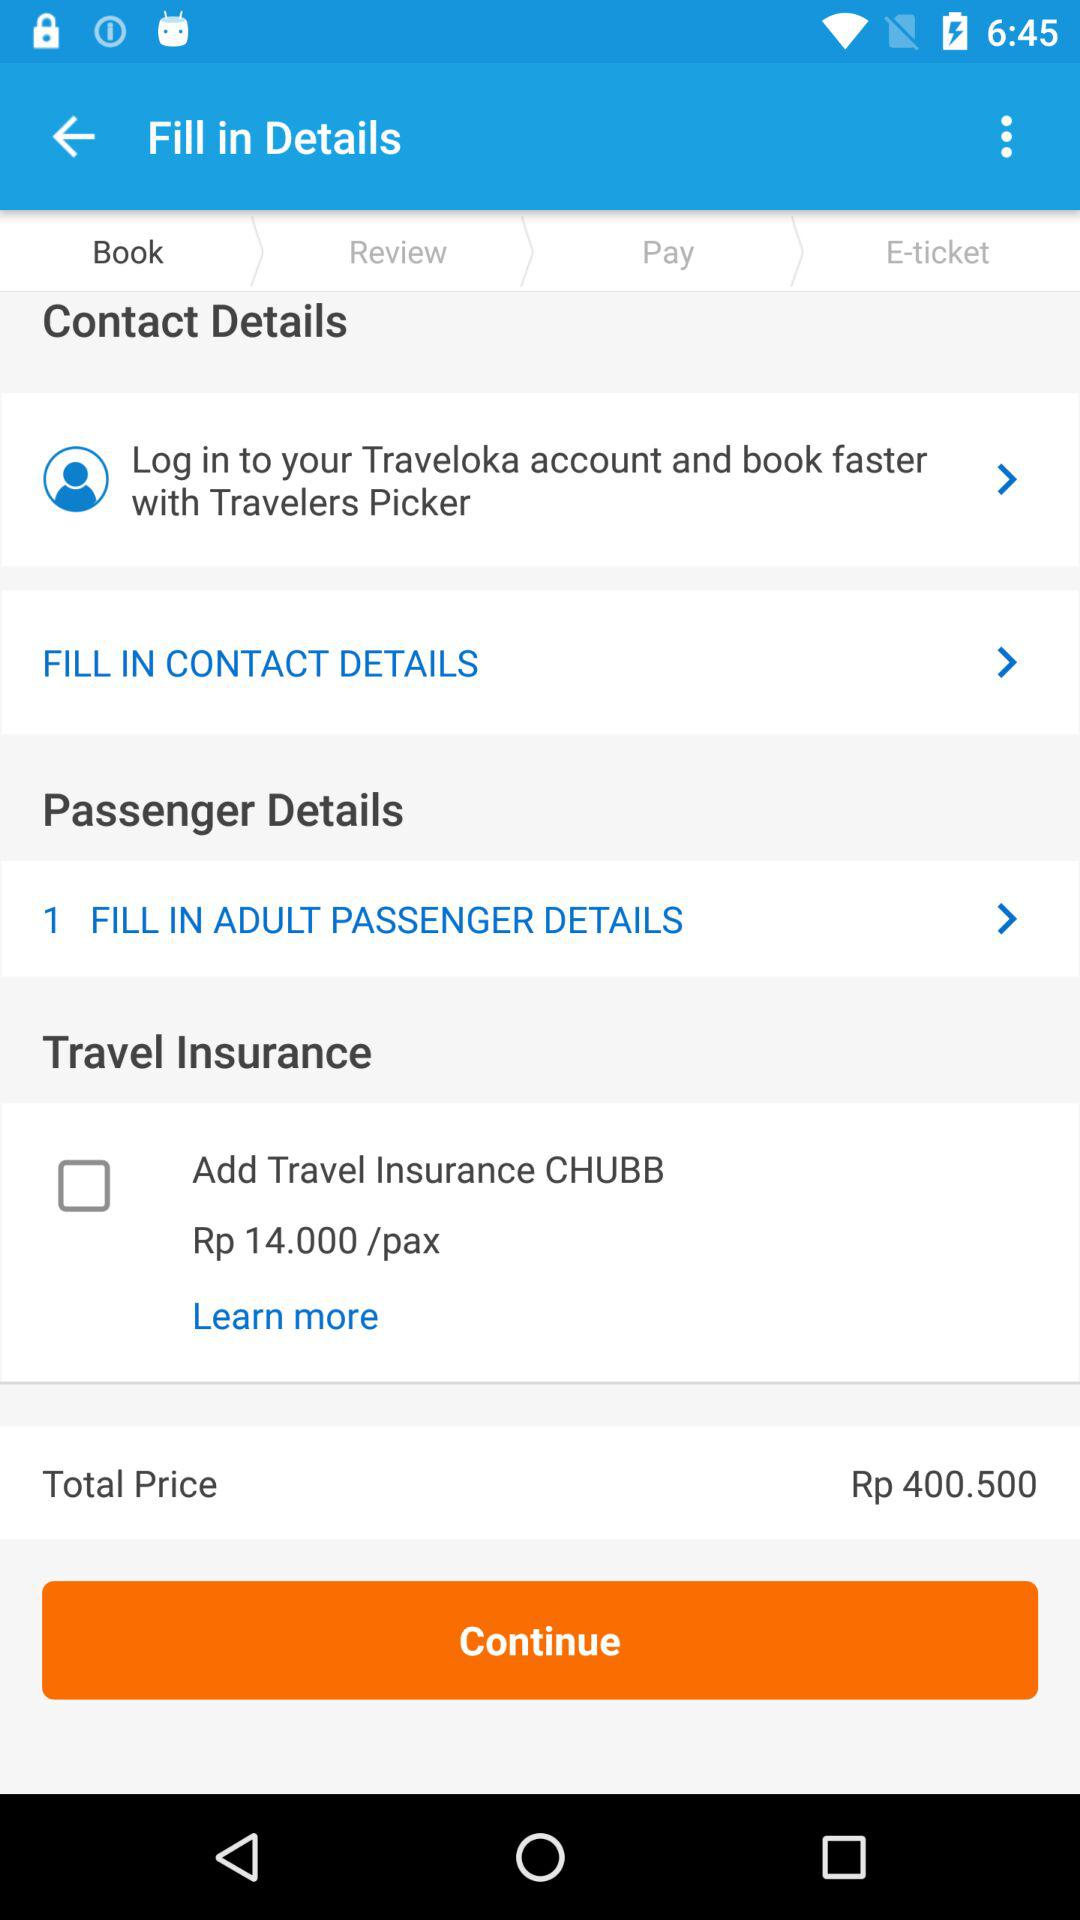How much is the total price of the ticket?
Answer the question using a single word or phrase. Rp 400.50 